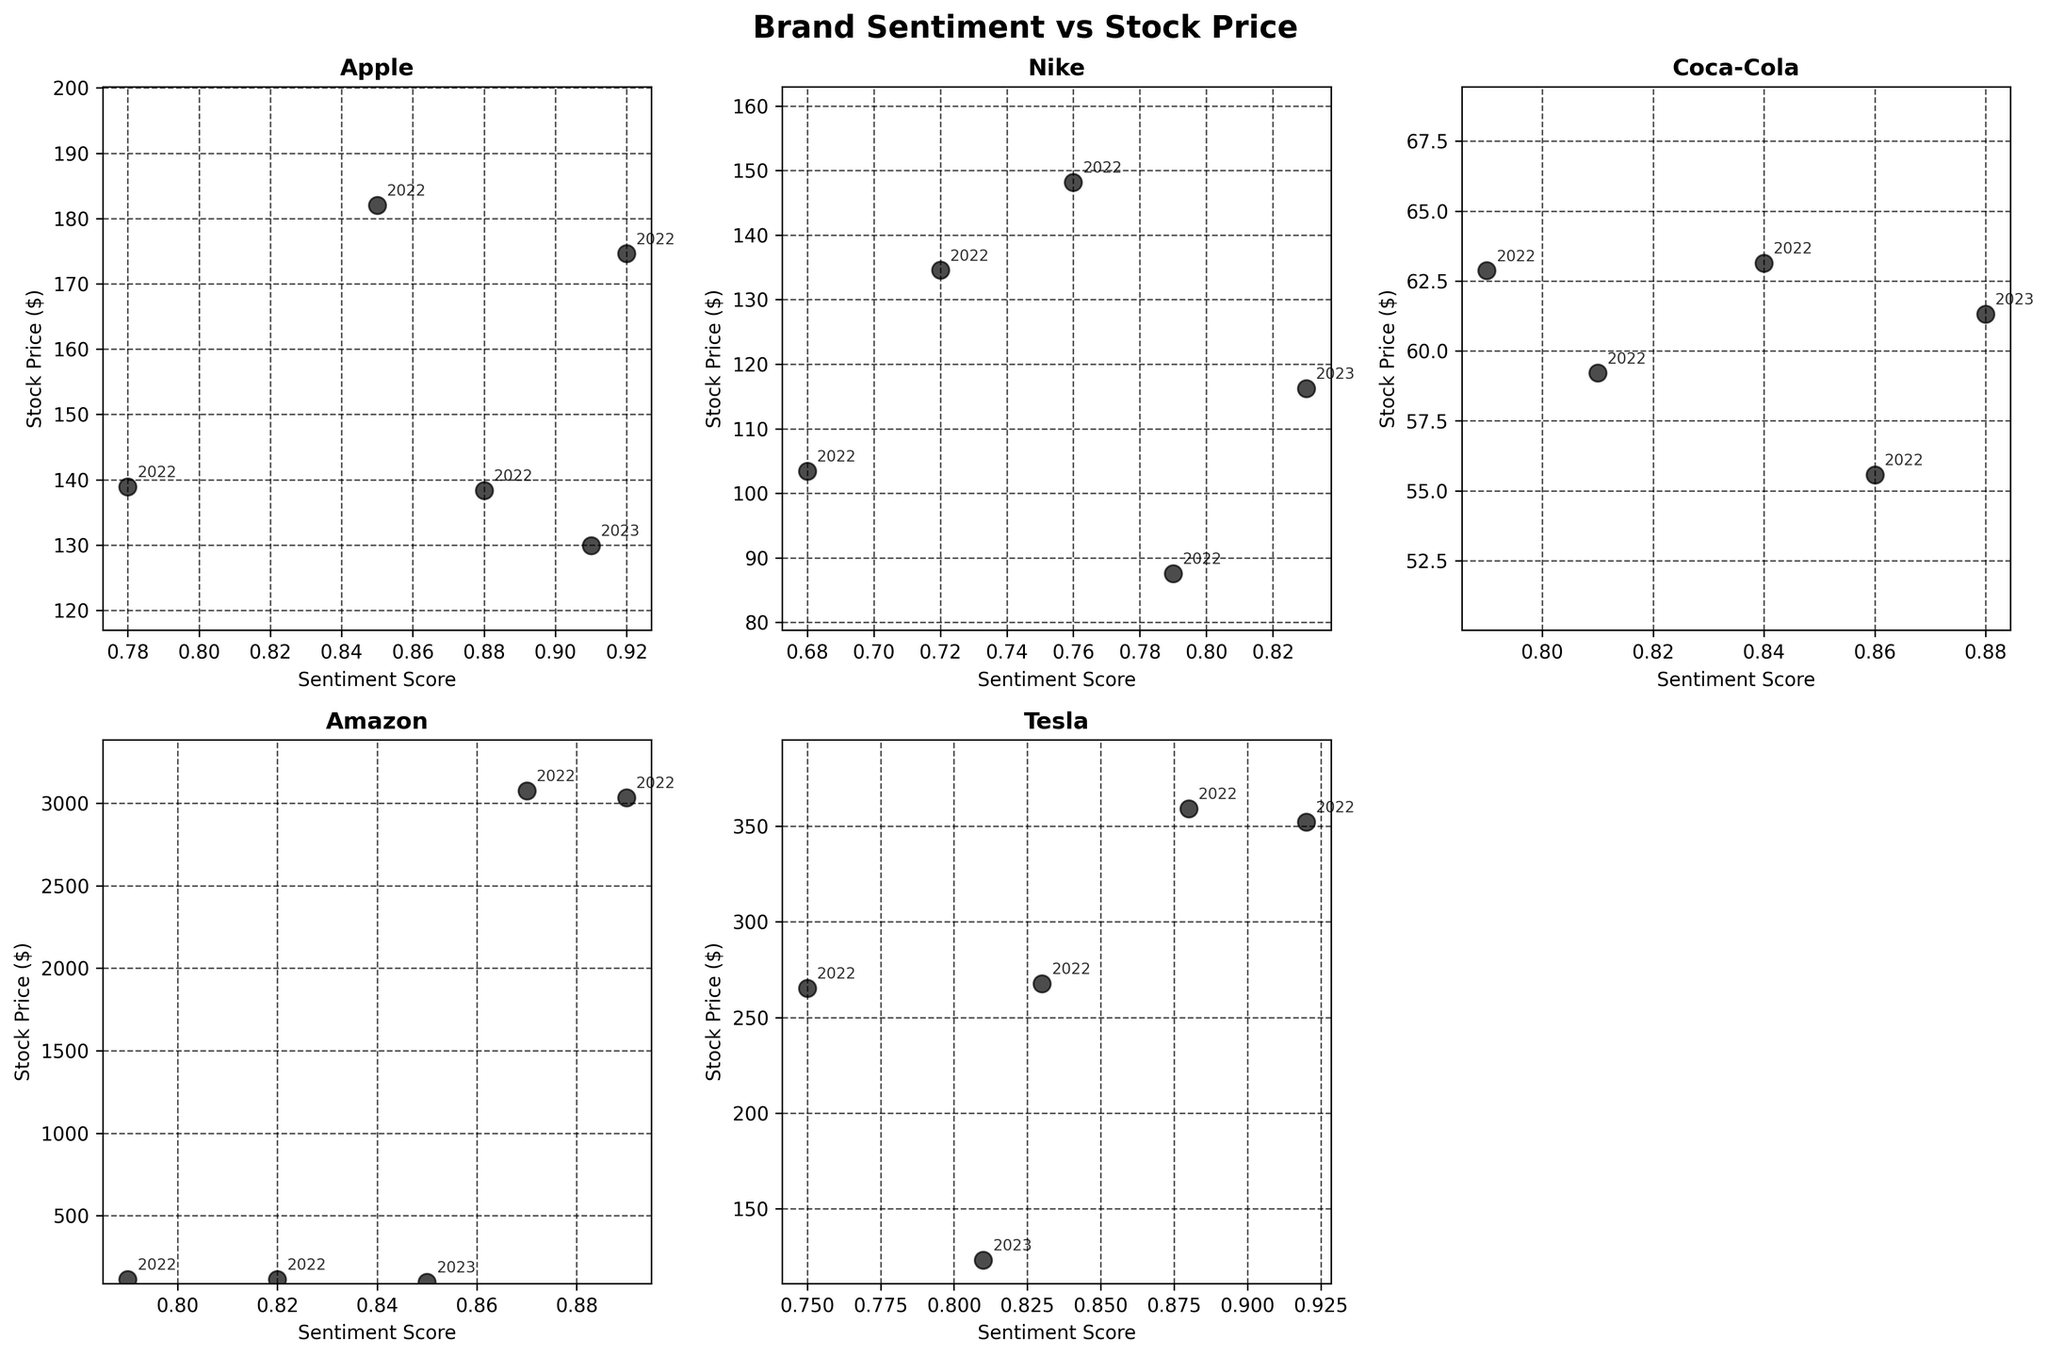What's the title of the figure? The title of the figure is usually located at the top of the plot. In this case, it should reflect what the plot is about.
Answer: Brand Sentiment vs Stock Price How many subplots are there? By counting the individual scatter plots within the figure, you can determine the total number of subplots.
Answer: 5 Which company shows a decreasing relationship between sentiment score and stock price from 2022-01-01 to 2023-01-01? By analyzing the trend lines in the individual subplots, observe how the sentiment score and stock price change over time. For the one that decreases, both variables should show a declining pattern.
Answer: Amazon What is the Sentiment Score for Nike on 2022-07-01? Find the data point labeled "2022-07-01" for Nike's subplot and note the corresponding sentiment score.
Answer: 0.68 Compare the stock price of Apple and Tesla on 2022-01-01. Which one is higher? Locate the data points for "2022-01-01" in both Apple and Tesla subplots and compare the stock prices.
Answer: Tesla Which company has the highest Sentiment Score in any given quarter? Look for the maximum sentiment score within all the subplots and identify the corresponding company.
Answer: Tesla How does Coca-Cola's stock price change from 2022-01-01 to 2023-01-01? Track the labeled data points within Coca-Cola's subplot from 2022-01-01 to 2023-01-01 and observe how the stock price fluctuates over that period.
Answer: Coca-Cola's stock price generally increases with minor fluctuations Do any companies' stock prices remain relatively stable across the observed period? Examine the individual subplots and identify any company where the stock price does not vary significantly over the time points.
Answer: Coca-Cola Which company showed a noticeable drop in sentiment score from one quarter to the next? Review each company's subplot for a significant decline in sentiment score between consecutive quarters and note the company.
Answer: Tesla from 2022-04-01 to 2022-07-01 How many data points are there for each company? Count the number of scatter points in each subplot, corresponding to the number of data entries for each company.
Answer: 5 